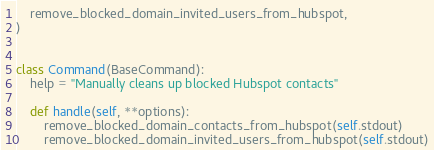<code> <loc_0><loc_0><loc_500><loc_500><_Python_>    remove_blocked_domain_invited_users_from_hubspot,
)


class Command(BaseCommand):
    help = "Manually cleans up blocked Hubspot contacts"

    def handle(self, **options):
        remove_blocked_domain_contacts_from_hubspot(self.stdout)
        remove_blocked_domain_invited_users_from_hubspot(self.stdout)
</code> 